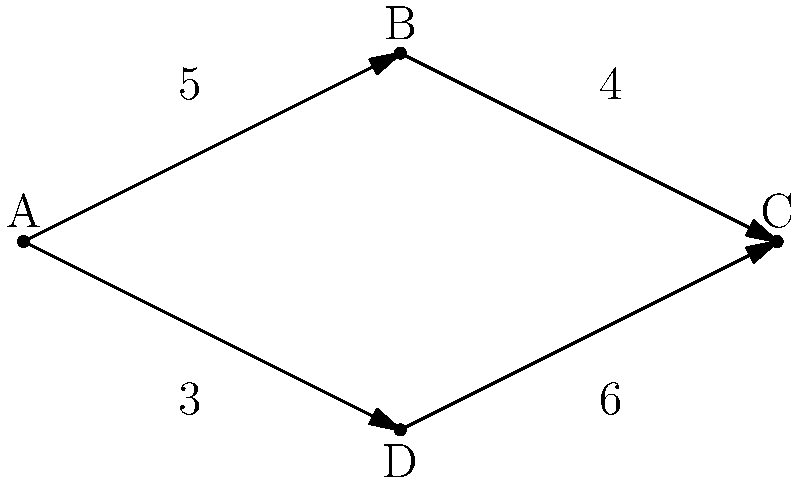As the dean of a prestigious business school, you're teaching a course on supply chain optimization. Given the network diagram above representing a supply chain network where the nodes are distribution centers and the edges represent transportation routes with their associated costs, what is the minimum cost path from node A to node C? To solve this problem, we'll use the following steps:

1. Identify all possible paths from A to C:
   - Path 1: A → B → C
   - Path 2: A → D → C

2. Calculate the cost of each path:
   - Path 1 cost: A → B (5) + B → C (4) = 5 + 4 = 9
   - Path 2 cost: A → D (3) + D → C (6) = 3 + 6 = 9

3. Compare the costs:
   Both paths have the same cost of 9.

4. Determine the minimum cost:
   Since both paths have the same cost, either can be considered the minimum cost path.

In this case, there are two minimum cost paths from A to C, both with a cost of 9.
Answer: 9 